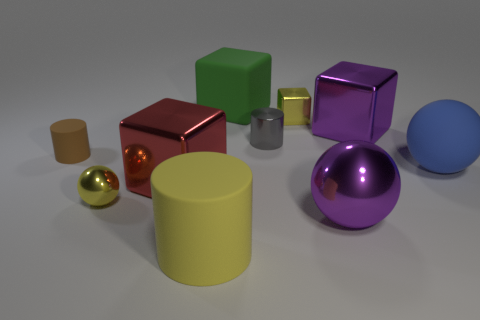Can you describe the lighting in the scene? The lighting in the scene is soft and diffused, casting gentle shadows on the surfaces underneath each object. It appears to be coming from the upper left, judging by the shadow directions. The reflections on the metallic surfaces suggest there is one primary light source, without harsh direct light. 